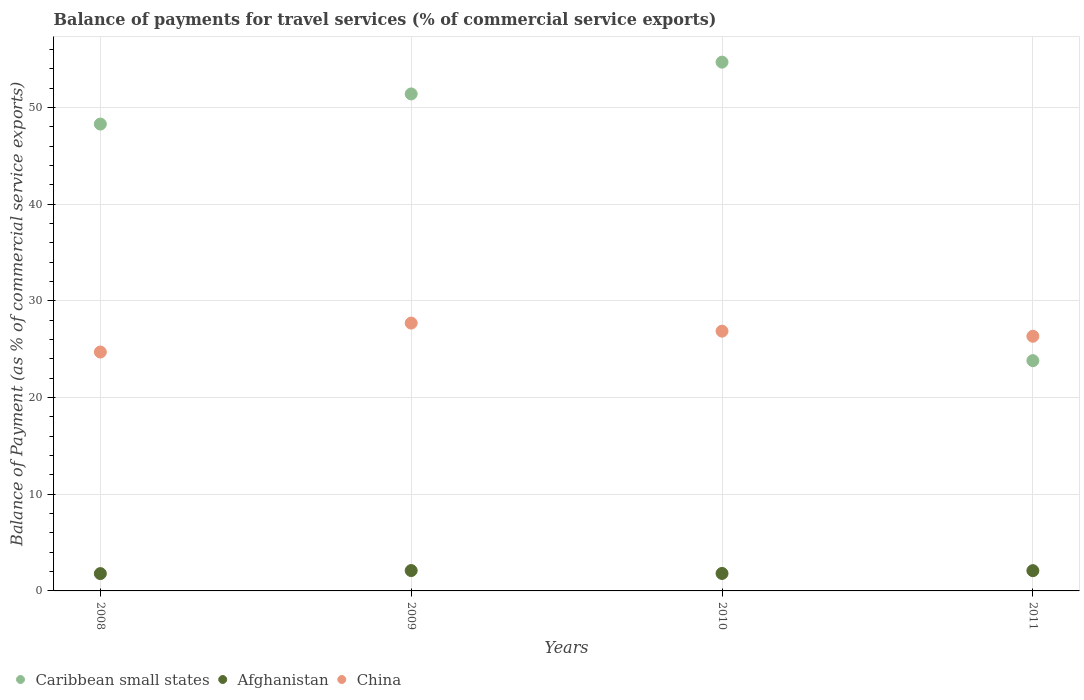Is the number of dotlines equal to the number of legend labels?
Your answer should be very brief. Yes. What is the balance of payments for travel services in Afghanistan in 2011?
Provide a succinct answer. 2.1. Across all years, what is the maximum balance of payments for travel services in Afghanistan?
Your response must be concise. 2.11. Across all years, what is the minimum balance of payments for travel services in China?
Ensure brevity in your answer.  24.7. In which year was the balance of payments for travel services in Afghanistan minimum?
Your answer should be compact. 2008. What is the total balance of payments for travel services in China in the graph?
Offer a very short reply. 105.61. What is the difference between the balance of payments for travel services in Caribbean small states in 2010 and that in 2011?
Offer a very short reply. 30.87. What is the difference between the balance of payments for travel services in Afghanistan in 2011 and the balance of payments for travel services in Caribbean small states in 2010?
Your answer should be compact. -52.59. What is the average balance of payments for travel services in Caribbean small states per year?
Offer a very short reply. 44.55. In the year 2010, what is the difference between the balance of payments for travel services in China and balance of payments for travel services in Afghanistan?
Keep it short and to the point. 25.06. What is the ratio of the balance of payments for travel services in Afghanistan in 2008 to that in 2010?
Ensure brevity in your answer.  0.99. Is the difference between the balance of payments for travel services in China in 2008 and 2010 greater than the difference between the balance of payments for travel services in Afghanistan in 2008 and 2010?
Make the answer very short. No. What is the difference between the highest and the second highest balance of payments for travel services in China?
Your answer should be compact. 0.83. What is the difference between the highest and the lowest balance of payments for travel services in China?
Your answer should be compact. 2.99. In how many years, is the balance of payments for travel services in Caribbean small states greater than the average balance of payments for travel services in Caribbean small states taken over all years?
Ensure brevity in your answer.  3. Does the balance of payments for travel services in China monotonically increase over the years?
Provide a short and direct response. No. How many dotlines are there?
Ensure brevity in your answer.  3. What is the difference between two consecutive major ticks on the Y-axis?
Ensure brevity in your answer.  10. Does the graph contain any zero values?
Your response must be concise. No. Where does the legend appear in the graph?
Provide a short and direct response. Bottom left. How many legend labels are there?
Provide a succinct answer. 3. What is the title of the graph?
Keep it short and to the point. Balance of payments for travel services (% of commercial service exports). Does "Tajikistan" appear as one of the legend labels in the graph?
Offer a terse response. No. What is the label or title of the Y-axis?
Your answer should be compact. Balance of Payment (as % of commercial service exports). What is the Balance of Payment (as % of commercial service exports) in Caribbean small states in 2008?
Make the answer very short. 48.28. What is the Balance of Payment (as % of commercial service exports) in Afghanistan in 2008?
Your answer should be very brief. 1.79. What is the Balance of Payment (as % of commercial service exports) of China in 2008?
Keep it short and to the point. 24.7. What is the Balance of Payment (as % of commercial service exports) of Caribbean small states in 2009?
Give a very brief answer. 51.4. What is the Balance of Payment (as % of commercial service exports) of Afghanistan in 2009?
Provide a succinct answer. 2.11. What is the Balance of Payment (as % of commercial service exports) in China in 2009?
Your response must be concise. 27.7. What is the Balance of Payment (as % of commercial service exports) of Caribbean small states in 2010?
Make the answer very short. 54.69. What is the Balance of Payment (as % of commercial service exports) in Afghanistan in 2010?
Your response must be concise. 1.81. What is the Balance of Payment (as % of commercial service exports) in China in 2010?
Offer a very short reply. 26.86. What is the Balance of Payment (as % of commercial service exports) in Caribbean small states in 2011?
Offer a terse response. 23.81. What is the Balance of Payment (as % of commercial service exports) in Afghanistan in 2011?
Provide a short and direct response. 2.1. What is the Balance of Payment (as % of commercial service exports) in China in 2011?
Give a very brief answer. 26.34. Across all years, what is the maximum Balance of Payment (as % of commercial service exports) of Caribbean small states?
Give a very brief answer. 54.69. Across all years, what is the maximum Balance of Payment (as % of commercial service exports) in Afghanistan?
Offer a terse response. 2.11. Across all years, what is the maximum Balance of Payment (as % of commercial service exports) in China?
Make the answer very short. 27.7. Across all years, what is the minimum Balance of Payment (as % of commercial service exports) of Caribbean small states?
Give a very brief answer. 23.81. Across all years, what is the minimum Balance of Payment (as % of commercial service exports) of Afghanistan?
Offer a terse response. 1.79. Across all years, what is the minimum Balance of Payment (as % of commercial service exports) in China?
Your answer should be very brief. 24.7. What is the total Balance of Payment (as % of commercial service exports) of Caribbean small states in the graph?
Provide a short and direct response. 178.18. What is the total Balance of Payment (as % of commercial service exports) in Afghanistan in the graph?
Provide a short and direct response. 7.8. What is the total Balance of Payment (as % of commercial service exports) in China in the graph?
Offer a terse response. 105.61. What is the difference between the Balance of Payment (as % of commercial service exports) of Caribbean small states in 2008 and that in 2009?
Your answer should be very brief. -3.12. What is the difference between the Balance of Payment (as % of commercial service exports) of Afghanistan in 2008 and that in 2009?
Your answer should be compact. -0.31. What is the difference between the Balance of Payment (as % of commercial service exports) in China in 2008 and that in 2009?
Ensure brevity in your answer.  -2.99. What is the difference between the Balance of Payment (as % of commercial service exports) in Caribbean small states in 2008 and that in 2010?
Provide a succinct answer. -6.4. What is the difference between the Balance of Payment (as % of commercial service exports) of Afghanistan in 2008 and that in 2010?
Make the answer very short. -0.02. What is the difference between the Balance of Payment (as % of commercial service exports) of China in 2008 and that in 2010?
Offer a terse response. -2.16. What is the difference between the Balance of Payment (as % of commercial service exports) of Caribbean small states in 2008 and that in 2011?
Ensure brevity in your answer.  24.47. What is the difference between the Balance of Payment (as % of commercial service exports) in Afghanistan in 2008 and that in 2011?
Provide a succinct answer. -0.3. What is the difference between the Balance of Payment (as % of commercial service exports) in China in 2008 and that in 2011?
Your answer should be very brief. -1.63. What is the difference between the Balance of Payment (as % of commercial service exports) of Caribbean small states in 2009 and that in 2010?
Provide a short and direct response. -3.29. What is the difference between the Balance of Payment (as % of commercial service exports) of Afghanistan in 2009 and that in 2010?
Provide a short and direct response. 0.3. What is the difference between the Balance of Payment (as % of commercial service exports) in China in 2009 and that in 2010?
Make the answer very short. 0.83. What is the difference between the Balance of Payment (as % of commercial service exports) in Caribbean small states in 2009 and that in 2011?
Make the answer very short. 27.58. What is the difference between the Balance of Payment (as % of commercial service exports) of Afghanistan in 2009 and that in 2011?
Ensure brevity in your answer.  0.01. What is the difference between the Balance of Payment (as % of commercial service exports) of China in 2009 and that in 2011?
Provide a short and direct response. 1.36. What is the difference between the Balance of Payment (as % of commercial service exports) in Caribbean small states in 2010 and that in 2011?
Give a very brief answer. 30.87. What is the difference between the Balance of Payment (as % of commercial service exports) in Afghanistan in 2010 and that in 2011?
Offer a terse response. -0.29. What is the difference between the Balance of Payment (as % of commercial service exports) in China in 2010 and that in 2011?
Ensure brevity in your answer.  0.53. What is the difference between the Balance of Payment (as % of commercial service exports) of Caribbean small states in 2008 and the Balance of Payment (as % of commercial service exports) of Afghanistan in 2009?
Provide a succinct answer. 46.18. What is the difference between the Balance of Payment (as % of commercial service exports) in Caribbean small states in 2008 and the Balance of Payment (as % of commercial service exports) in China in 2009?
Make the answer very short. 20.58. What is the difference between the Balance of Payment (as % of commercial service exports) of Afghanistan in 2008 and the Balance of Payment (as % of commercial service exports) of China in 2009?
Give a very brief answer. -25.91. What is the difference between the Balance of Payment (as % of commercial service exports) in Caribbean small states in 2008 and the Balance of Payment (as % of commercial service exports) in Afghanistan in 2010?
Make the answer very short. 46.48. What is the difference between the Balance of Payment (as % of commercial service exports) in Caribbean small states in 2008 and the Balance of Payment (as % of commercial service exports) in China in 2010?
Offer a terse response. 21.42. What is the difference between the Balance of Payment (as % of commercial service exports) of Afghanistan in 2008 and the Balance of Payment (as % of commercial service exports) of China in 2010?
Give a very brief answer. -25.07. What is the difference between the Balance of Payment (as % of commercial service exports) of Caribbean small states in 2008 and the Balance of Payment (as % of commercial service exports) of Afghanistan in 2011?
Provide a succinct answer. 46.19. What is the difference between the Balance of Payment (as % of commercial service exports) of Caribbean small states in 2008 and the Balance of Payment (as % of commercial service exports) of China in 2011?
Ensure brevity in your answer.  21.94. What is the difference between the Balance of Payment (as % of commercial service exports) in Afghanistan in 2008 and the Balance of Payment (as % of commercial service exports) in China in 2011?
Your answer should be very brief. -24.55. What is the difference between the Balance of Payment (as % of commercial service exports) of Caribbean small states in 2009 and the Balance of Payment (as % of commercial service exports) of Afghanistan in 2010?
Provide a short and direct response. 49.59. What is the difference between the Balance of Payment (as % of commercial service exports) of Caribbean small states in 2009 and the Balance of Payment (as % of commercial service exports) of China in 2010?
Provide a succinct answer. 24.53. What is the difference between the Balance of Payment (as % of commercial service exports) in Afghanistan in 2009 and the Balance of Payment (as % of commercial service exports) in China in 2010?
Provide a short and direct response. -24.76. What is the difference between the Balance of Payment (as % of commercial service exports) in Caribbean small states in 2009 and the Balance of Payment (as % of commercial service exports) in Afghanistan in 2011?
Ensure brevity in your answer.  49.3. What is the difference between the Balance of Payment (as % of commercial service exports) of Caribbean small states in 2009 and the Balance of Payment (as % of commercial service exports) of China in 2011?
Your response must be concise. 25.06. What is the difference between the Balance of Payment (as % of commercial service exports) of Afghanistan in 2009 and the Balance of Payment (as % of commercial service exports) of China in 2011?
Give a very brief answer. -24.23. What is the difference between the Balance of Payment (as % of commercial service exports) of Caribbean small states in 2010 and the Balance of Payment (as % of commercial service exports) of Afghanistan in 2011?
Your answer should be compact. 52.59. What is the difference between the Balance of Payment (as % of commercial service exports) of Caribbean small states in 2010 and the Balance of Payment (as % of commercial service exports) of China in 2011?
Offer a very short reply. 28.35. What is the difference between the Balance of Payment (as % of commercial service exports) of Afghanistan in 2010 and the Balance of Payment (as % of commercial service exports) of China in 2011?
Provide a short and direct response. -24.53. What is the average Balance of Payment (as % of commercial service exports) of Caribbean small states per year?
Provide a short and direct response. 44.55. What is the average Balance of Payment (as % of commercial service exports) of Afghanistan per year?
Your response must be concise. 1.95. What is the average Balance of Payment (as % of commercial service exports) of China per year?
Make the answer very short. 26.4. In the year 2008, what is the difference between the Balance of Payment (as % of commercial service exports) of Caribbean small states and Balance of Payment (as % of commercial service exports) of Afghanistan?
Your response must be concise. 46.49. In the year 2008, what is the difference between the Balance of Payment (as % of commercial service exports) of Caribbean small states and Balance of Payment (as % of commercial service exports) of China?
Your response must be concise. 23.58. In the year 2008, what is the difference between the Balance of Payment (as % of commercial service exports) of Afghanistan and Balance of Payment (as % of commercial service exports) of China?
Your answer should be very brief. -22.91. In the year 2009, what is the difference between the Balance of Payment (as % of commercial service exports) of Caribbean small states and Balance of Payment (as % of commercial service exports) of Afghanistan?
Your answer should be compact. 49.29. In the year 2009, what is the difference between the Balance of Payment (as % of commercial service exports) in Caribbean small states and Balance of Payment (as % of commercial service exports) in China?
Give a very brief answer. 23.7. In the year 2009, what is the difference between the Balance of Payment (as % of commercial service exports) of Afghanistan and Balance of Payment (as % of commercial service exports) of China?
Your answer should be compact. -25.59. In the year 2010, what is the difference between the Balance of Payment (as % of commercial service exports) of Caribbean small states and Balance of Payment (as % of commercial service exports) of Afghanistan?
Make the answer very short. 52.88. In the year 2010, what is the difference between the Balance of Payment (as % of commercial service exports) of Caribbean small states and Balance of Payment (as % of commercial service exports) of China?
Ensure brevity in your answer.  27.82. In the year 2010, what is the difference between the Balance of Payment (as % of commercial service exports) of Afghanistan and Balance of Payment (as % of commercial service exports) of China?
Make the answer very short. -25.06. In the year 2011, what is the difference between the Balance of Payment (as % of commercial service exports) in Caribbean small states and Balance of Payment (as % of commercial service exports) in Afghanistan?
Make the answer very short. 21.72. In the year 2011, what is the difference between the Balance of Payment (as % of commercial service exports) of Caribbean small states and Balance of Payment (as % of commercial service exports) of China?
Provide a succinct answer. -2.52. In the year 2011, what is the difference between the Balance of Payment (as % of commercial service exports) in Afghanistan and Balance of Payment (as % of commercial service exports) in China?
Offer a very short reply. -24.24. What is the ratio of the Balance of Payment (as % of commercial service exports) in Caribbean small states in 2008 to that in 2009?
Offer a very short reply. 0.94. What is the ratio of the Balance of Payment (as % of commercial service exports) in Afghanistan in 2008 to that in 2009?
Your answer should be compact. 0.85. What is the ratio of the Balance of Payment (as % of commercial service exports) in China in 2008 to that in 2009?
Your response must be concise. 0.89. What is the ratio of the Balance of Payment (as % of commercial service exports) of Caribbean small states in 2008 to that in 2010?
Offer a terse response. 0.88. What is the ratio of the Balance of Payment (as % of commercial service exports) in Afghanistan in 2008 to that in 2010?
Give a very brief answer. 0.99. What is the ratio of the Balance of Payment (as % of commercial service exports) in China in 2008 to that in 2010?
Keep it short and to the point. 0.92. What is the ratio of the Balance of Payment (as % of commercial service exports) of Caribbean small states in 2008 to that in 2011?
Offer a very short reply. 2.03. What is the ratio of the Balance of Payment (as % of commercial service exports) of Afghanistan in 2008 to that in 2011?
Provide a short and direct response. 0.86. What is the ratio of the Balance of Payment (as % of commercial service exports) in China in 2008 to that in 2011?
Provide a succinct answer. 0.94. What is the ratio of the Balance of Payment (as % of commercial service exports) in Caribbean small states in 2009 to that in 2010?
Offer a terse response. 0.94. What is the ratio of the Balance of Payment (as % of commercial service exports) in Afghanistan in 2009 to that in 2010?
Keep it short and to the point. 1.16. What is the ratio of the Balance of Payment (as % of commercial service exports) in China in 2009 to that in 2010?
Your response must be concise. 1.03. What is the ratio of the Balance of Payment (as % of commercial service exports) in Caribbean small states in 2009 to that in 2011?
Offer a terse response. 2.16. What is the ratio of the Balance of Payment (as % of commercial service exports) in China in 2009 to that in 2011?
Give a very brief answer. 1.05. What is the ratio of the Balance of Payment (as % of commercial service exports) in Caribbean small states in 2010 to that in 2011?
Your response must be concise. 2.3. What is the ratio of the Balance of Payment (as % of commercial service exports) of Afghanistan in 2010 to that in 2011?
Provide a short and direct response. 0.86. What is the difference between the highest and the second highest Balance of Payment (as % of commercial service exports) in Caribbean small states?
Make the answer very short. 3.29. What is the difference between the highest and the second highest Balance of Payment (as % of commercial service exports) in Afghanistan?
Your answer should be compact. 0.01. What is the difference between the highest and the second highest Balance of Payment (as % of commercial service exports) of China?
Ensure brevity in your answer.  0.83. What is the difference between the highest and the lowest Balance of Payment (as % of commercial service exports) in Caribbean small states?
Ensure brevity in your answer.  30.87. What is the difference between the highest and the lowest Balance of Payment (as % of commercial service exports) in Afghanistan?
Ensure brevity in your answer.  0.31. What is the difference between the highest and the lowest Balance of Payment (as % of commercial service exports) of China?
Provide a short and direct response. 2.99. 